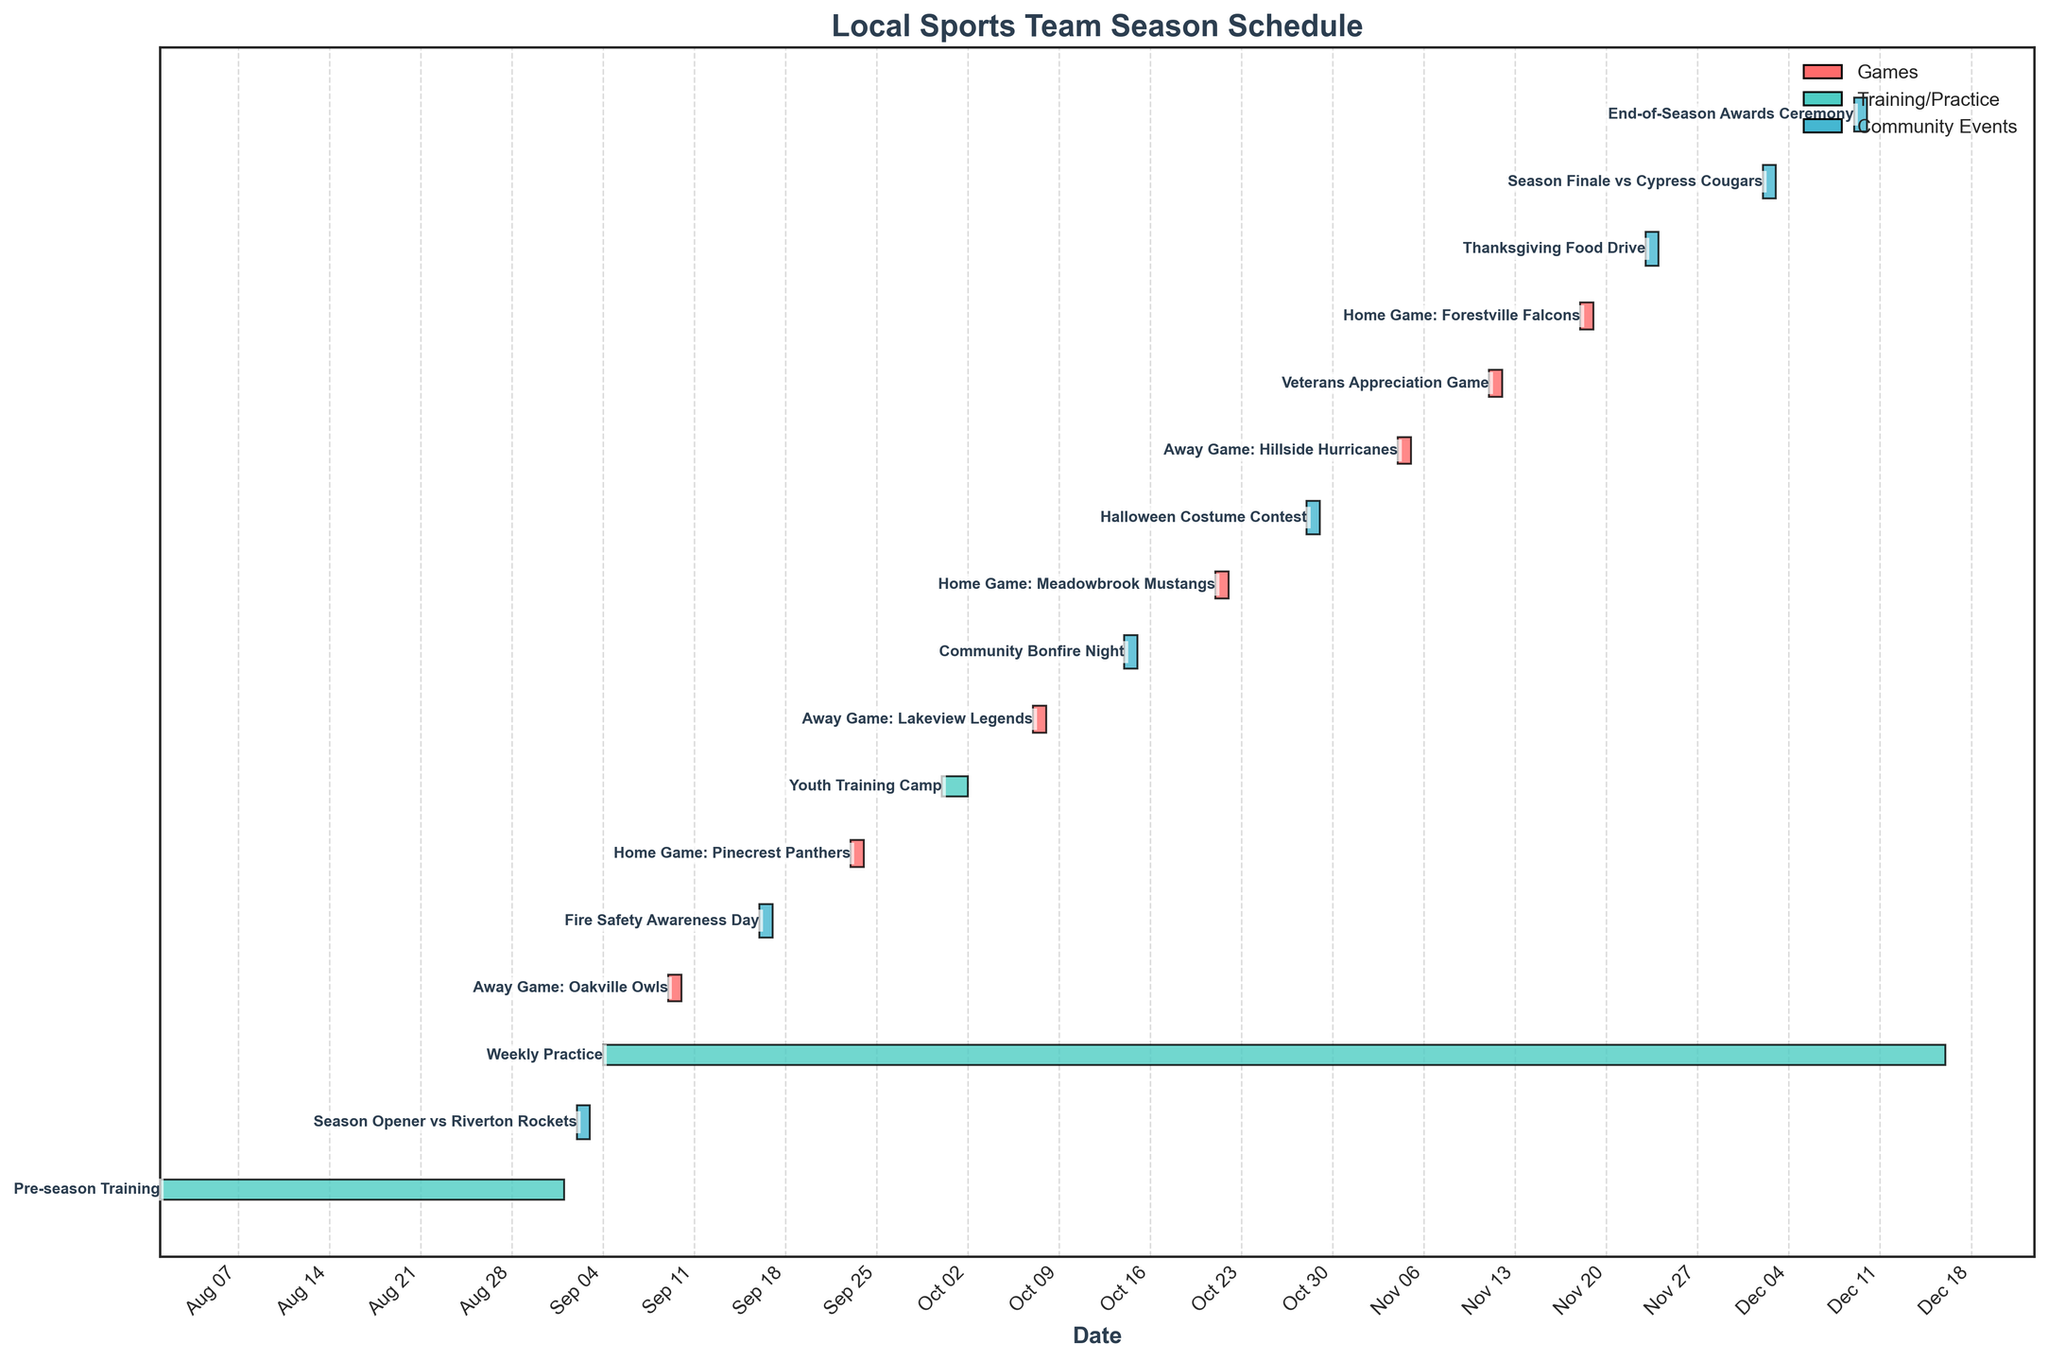What's the title of the figure? The title of the figure is displayed prominently at the top of the chart. By reading the title, we can understand the general purpose of the figure.
Answer: Local Sports Team Season Schedule When does the pre-season training start and end? The pre-season training bar is the first bar at the top of the Gantt chart. The start date is marked at the beginning of the bar, and the end date is marked at the end of the bar.
Answer: 2023-08-01 to 2023-08-31 How many games are scheduled throughout the season? To find the number of games, count the bars labeled with task names indicating a game. These bars are usually colored differently from training and community events.
Answer: 7 What is the duration of the weekly practice sessions? The weekly practice bar extends over multiple weeks. To determine the duration, check the start and end dates at the edges of the bar.
Answer: 2023-09-04 to 2023-12-15 Which event takes place on September 16, 2023? Locate the date September 16, 2023, on the chart's date axis. The corresponding bar on that date will be labeled with the event.
Answer: Fire Safety Awareness Day Which type of event occupies the most space on the chart? Visually compare the color-coded bars representing practice sessions, games, and community events. The type with the most extended presence along the horizontal axis occupies the most space.
Answer: Weekly Practice What are the dates for the Youth Training Camp? Locate the bar labeled "Youth Training Camp" and check the dates at the start and end of this bar.
Answer: 2023-09-30 to 2023-10-01 Which game is scheduled after the Home Game against the Meadowbrook Mustangs? Find the bar labeled "Home Game: Meadowbrook Mustangs," then look for the next game bar that follows it.
Answer: Away Game: Hillside Hurricanes How many community engagement events are scheduled in October? Count the number of bars representing community events in the month of October by checking the event labels and dates along the chart's axis.
Answer: 2 What's the duration between the Season Finale and the End-of-Season Awards Ceremony? Determine the dates for the "Season Finale vs Cypress Cougars" and the "End-of-Season Awards Ceremony." Calculate the number of days between these two dates by counting the days after the Season Finale until the Awards Ceremony.
Answer: 7 days 